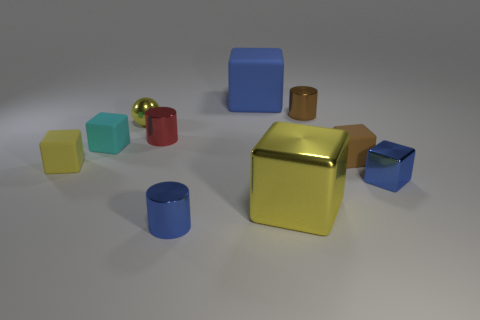Subtract 1 cubes. How many cubes are left? 5 Subtract all brown blocks. How many blocks are left? 5 Subtract all cyan cubes. How many cubes are left? 5 Subtract all purple cubes. Subtract all yellow spheres. How many cubes are left? 6 Subtract all cylinders. How many objects are left? 7 Subtract 0 brown balls. How many objects are left? 10 Subtract all small brown objects. Subtract all yellow matte cubes. How many objects are left? 7 Add 7 small brown metallic cylinders. How many small brown metallic cylinders are left? 8 Add 1 rubber things. How many rubber things exist? 5 